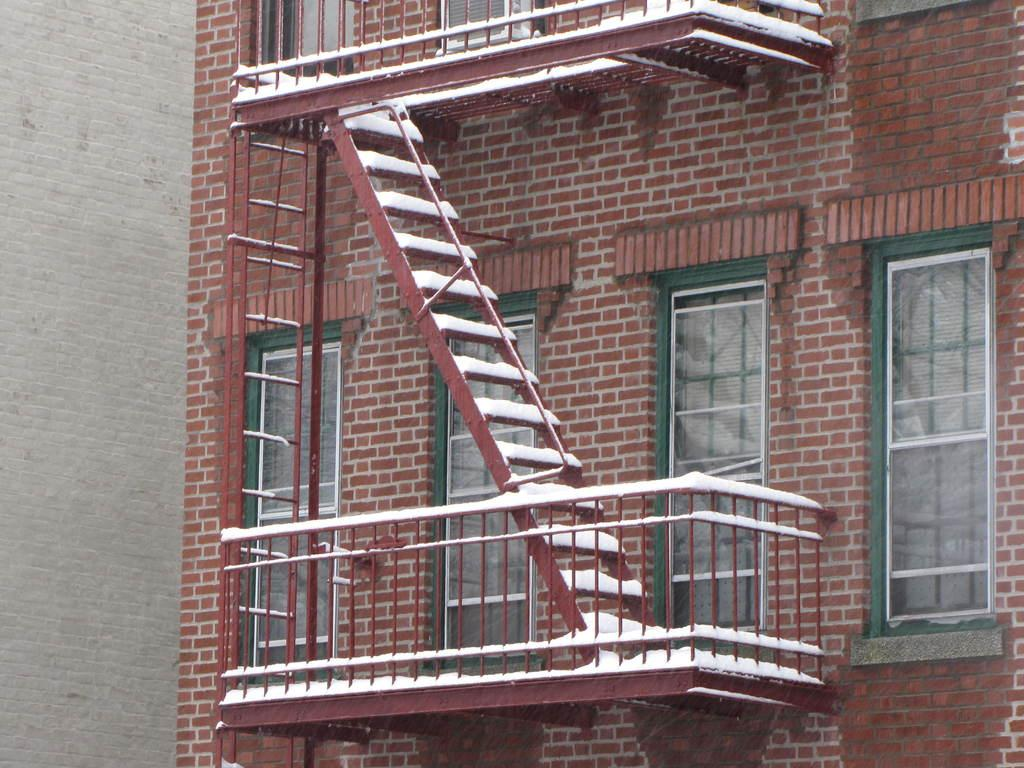What is the main subject of the image? The main subject of the image is a building. What type of material is used for the building's wall? The building has a brick wall. Are there any architectural features visible in the image? Yes, there are steps in the image. What can be seen on the building's exterior? The building has windows and railings. What type of quince is being served in the building's dining area? There is no dining area or quince present in the image; it only features a building with specific architectural features. 